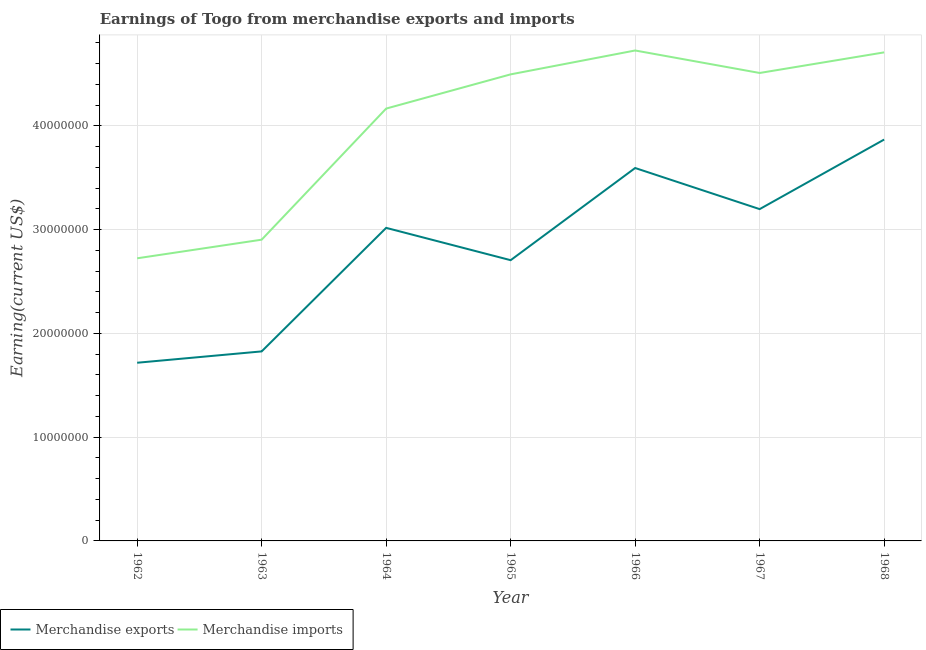Does the line corresponding to earnings from merchandise imports intersect with the line corresponding to earnings from merchandise exports?
Your answer should be very brief. No. Is the number of lines equal to the number of legend labels?
Offer a terse response. Yes. What is the earnings from merchandise imports in 1966?
Your response must be concise. 4.73e+07. Across all years, what is the maximum earnings from merchandise imports?
Keep it short and to the point. 4.73e+07. Across all years, what is the minimum earnings from merchandise imports?
Provide a succinct answer. 2.72e+07. In which year was the earnings from merchandise exports maximum?
Provide a short and direct response. 1968. In which year was the earnings from merchandise imports minimum?
Your answer should be compact. 1962. What is the total earnings from merchandise imports in the graph?
Offer a very short reply. 2.82e+08. What is the difference between the earnings from merchandise exports in 1962 and that in 1966?
Give a very brief answer. -1.88e+07. What is the difference between the earnings from merchandise imports in 1968 and the earnings from merchandise exports in 1963?
Your answer should be very brief. 2.88e+07. What is the average earnings from merchandise imports per year?
Keep it short and to the point. 4.03e+07. In the year 1964, what is the difference between the earnings from merchandise imports and earnings from merchandise exports?
Offer a terse response. 1.15e+07. In how many years, is the earnings from merchandise imports greater than 6000000 US$?
Make the answer very short. 7. What is the ratio of the earnings from merchandise exports in 1964 to that in 1967?
Offer a terse response. 0.94. Is the difference between the earnings from merchandise exports in 1967 and 1968 greater than the difference between the earnings from merchandise imports in 1967 and 1968?
Your answer should be compact. No. What is the difference between the highest and the second highest earnings from merchandise exports?
Offer a very short reply. 2.74e+06. What is the difference between the highest and the lowest earnings from merchandise exports?
Make the answer very short. 2.15e+07. Does the earnings from merchandise exports monotonically increase over the years?
Offer a very short reply. No. Is the earnings from merchandise exports strictly less than the earnings from merchandise imports over the years?
Offer a very short reply. Yes. How many lines are there?
Keep it short and to the point. 2. Does the graph contain any zero values?
Your answer should be compact. No. Does the graph contain grids?
Keep it short and to the point. Yes. Where does the legend appear in the graph?
Your answer should be very brief. Bottom left. How many legend labels are there?
Provide a short and direct response. 2. How are the legend labels stacked?
Provide a short and direct response. Horizontal. What is the title of the graph?
Provide a succinct answer. Earnings of Togo from merchandise exports and imports. What is the label or title of the X-axis?
Give a very brief answer. Year. What is the label or title of the Y-axis?
Your answer should be very brief. Earning(current US$). What is the Earning(current US$) of Merchandise exports in 1962?
Give a very brief answer. 1.72e+07. What is the Earning(current US$) of Merchandise imports in 1962?
Your answer should be compact. 2.72e+07. What is the Earning(current US$) of Merchandise exports in 1963?
Offer a very short reply. 1.83e+07. What is the Earning(current US$) in Merchandise imports in 1963?
Provide a short and direct response. 2.90e+07. What is the Earning(current US$) in Merchandise exports in 1964?
Give a very brief answer. 3.02e+07. What is the Earning(current US$) in Merchandise imports in 1964?
Offer a very short reply. 4.17e+07. What is the Earning(current US$) in Merchandise exports in 1965?
Provide a short and direct response. 2.71e+07. What is the Earning(current US$) of Merchandise imports in 1965?
Your response must be concise. 4.50e+07. What is the Earning(current US$) of Merchandise exports in 1966?
Provide a short and direct response. 3.59e+07. What is the Earning(current US$) of Merchandise imports in 1966?
Your response must be concise. 4.73e+07. What is the Earning(current US$) in Merchandise exports in 1967?
Give a very brief answer. 3.20e+07. What is the Earning(current US$) of Merchandise imports in 1967?
Provide a succinct answer. 4.51e+07. What is the Earning(current US$) of Merchandise exports in 1968?
Offer a very short reply. 3.87e+07. What is the Earning(current US$) of Merchandise imports in 1968?
Your answer should be compact. 4.71e+07. Across all years, what is the maximum Earning(current US$) in Merchandise exports?
Provide a short and direct response. 3.87e+07. Across all years, what is the maximum Earning(current US$) in Merchandise imports?
Give a very brief answer. 4.73e+07. Across all years, what is the minimum Earning(current US$) in Merchandise exports?
Offer a terse response. 1.72e+07. Across all years, what is the minimum Earning(current US$) of Merchandise imports?
Your response must be concise. 2.72e+07. What is the total Earning(current US$) of Merchandise exports in the graph?
Ensure brevity in your answer.  1.99e+08. What is the total Earning(current US$) in Merchandise imports in the graph?
Make the answer very short. 2.82e+08. What is the difference between the Earning(current US$) in Merchandise exports in 1962 and that in 1963?
Your answer should be compact. -1.09e+06. What is the difference between the Earning(current US$) in Merchandise imports in 1962 and that in 1963?
Make the answer very short. -1.79e+06. What is the difference between the Earning(current US$) of Merchandise exports in 1962 and that in 1964?
Ensure brevity in your answer.  -1.30e+07. What is the difference between the Earning(current US$) of Merchandise imports in 1962 and that in 1964?
Ensure brevity in your answer.  -1.44e+07. What is the difference between the Earning(current US$) in Merchandise exports in 1962 and that in 1965?
Your answer should be compact. -9.88e+06. What is the difference between the Earning(current US$) of Merchandise imports in 1962 and that in 1965?
Your response must be concise. -1.77e+07. What is the difference between the Earning(current US$) in Merchandise exports in 1962 and that in 1966?
Your answer should be compact. -1.88e+07. What is the difference between the Earning(current US$) in Merchandise imports in 1962 and that in 1966?
Make the answer very short. -2.00e+07. What is the difference between the Earning(current US$) in Merchandise exports in 1962 and that in 1967?
Provide a short and direct response. -1.48e+07. What is the difference between the Earning(current US$) in Merchandise imports in 1962 and that in 1967?
Your answer should be very brief. -1.79e+07. What is the difference between the Earning(current US$) in Merchandise exports in 1962 and that in 1968?
Offer a very short reply. -2.15e+07. What is the difference between the Earning(current US$) of Merchandise imports in 1962 and that in 1968?
Your answer should be very brief. -1.98e+07. What is the difference between the Earning(current US$) in Merchandise exports in 1963 and that in 1964?
Your answer should be very brief. -1.19e+07. What is the difference between the Earning(current US$) of Merchandise imports in 1963 and that in 1964?
Keep it short and to the point. -1.26e+07. What is the difference between the Earning(current US$) of Merchandise exports in 1963 and that in 1965?
Your response must be concise. -8.79e+06. What is the difference between the Earning(current US$) of Merchandise imports in 1963 and that in 1965?
Your response must be concise. -1.59e+07. What is the difference between the Earning(current US$) in Merchandise exports in 1963 and that in 1966?
Offer a terse response. -1.77e+07. What is the difference between the Earning(current US$) in Merchandise imports in 1963 and that in 1966?
Make the answer very short. -1.82e+07. What is the difference between the Earning(current US$) of Merchandise exports in 1963 and that in 1967?
Your answer should be compact. -1.37e+07. What is the difference between the Earning(current US$) in Merchandise imports in 1963 and that in 1967?
Ensure brevity in your answer.  -1.61e+07. What is the difference between the Earning(current US$) of Merchandise exports in 1963 and that in 1968?
Your answer should be compact. -2.04e+07. What is the difference between the Earning(current US$) in Merchandise imports in 1963 and that in 1968?
Ensure brevity in your answer.  -1.81e+07. What is the difference between the Earning(current US$) in Merchandise exports in 1964 and that in 1965?
Make the answer very short. 3.12e+06. What is the difference between the Earning(current US$) in Merchandise imports in 1964 and that in 1965?
Keep it short and to the point. -3.30e+06. What is the difference between the Earning(current US$) of Merchandise exports in 1964 and that in 1966?
Offer a very short reply. -5.77e+06. What is the difference between the Earning(current US$) of Merchandise imports in 1964 and that in 1966?
Your answer should be compact. -5.60e+06. What is the difference between the Earning(current US$) of Merchandise exports in 1964 and that in 1967?
Your answer should be very brief. -1.81e+06. What is the difference between the Earning(current US$) in Merchandise imports in 1964 and that in 1967?
Your response must be concise. -3.43e+06. What is the difference between the Earning(current US$) of Merchandise exports in 1964 and that in 1968?
Make the answer very short. -8.51e+06. What is the difference between the Earning(current US$) of Merchandise imports in 1964 and that in 1968?
Your answer should be compact. -5.42e+06. What is the difference between the Earning(current US$) of Merchandise exports in 1965 and that in 1966?
Your answer should be compact. -8.88e+06. What is the difference between the Earning(current US$) of Merchandise imports in 1965 and that in 1966?
Offer a very short reply. -2.30e+06. What is the difference between the Earning(current US$) of Merchandise exports in 1965 and that in 1967?
Keep it short and to the point. -4.92e+06. What is the difference between the Earning(current US$) in Merchandise imports in 1965 and that in 1967?
Provide a short and direct response. -1.34e+05. What is the difference between the Earning(current US$) of Merchandise exports in 1965 and that in 1968?
Provide a short and direct response. -1.16e+07. What is the difference between the Earning(current US$) of Merchandise imports in 1965 and that in 1968?
Keep it short and to the point. -2.12e+06. What is the difference between the Earning(current US$) of Merchandise exports in 1966 and that in 1967?
Your answer should be compact. 3.96e+06. What is the difference between the Earning(current US$) of Merchandise imports in 1966 and that in 1967?
Provide a succinct answer. 2.17e+06. What is the difference between the Earning(current US$) in Merchandise exports in 1966 and that in 1968?
Make the answer very short. -2.74e+06. What is the difference between the Earning(current US$) of Merchandise imports in 1966 and that in 1968?
Offer a very short reply. 1.82e+05. What is the difference between the Earning(current US$) of Merchandise exports in 1967 and that in 1968?
Your answer should be very brief. -6.70e+06. What is the difference between the Earning(current US$) in Merchandise imports in 1967 and that in 1968?
Offer a terse response. -1.98e+06. What is the difference between the Earning(current US$) of Merchandise exports in 1962 and the Earning(current US$) of Merchandise imports in 1963?
Give a very brief answer. -1.19e+07. What is the difference between the Earning(current US$) in Merchandise exports in 1962 and the Earning(current US$) in Merchandise imports in 1964?
Offer a terse response. -2.45e+07. What is the difference between the Earning(current US$) in Merchandise exports in 1962 and the Earning(current US$) in Merchandise imports in 1965?
Keep it short and to the point. -2.78e+07. What is the difference between the Earning(current US$) of Merchandise exports in 1962 and the Earning(current US$) of Merchandise imports in 1966?
Your answer should be compact. -3.01e+07. What is the difference between the Earning(current US$) in Merchandise exports in 1962 and the Earning(current US$) in Merchandise imports in 1967?
Your response must be concise. -2.79e+07. What is the difference between the Earning(current US$) of Merchandise exports in 1962 and the Earning(current US$) of Merchandise imports in 1968?
Offer a very short reply. -2.99e+07. What is the difference between the Earning(current US$) of Merchandise exports in 1963 and the Earning(current US$) of Merchandise imports in 1964?
Ensure brevity in your answer.  -2.34e+07. What is the difference between the Earning(current US$) in Merchandise exports in 1963 and the Earning(current US$) in Merchandise imports in 1965?
Keep it short and to the point. -2.67e+07. What is the difference between the Earning(current US$) of Merchandise exports in 1963 and the Earning(current US$) of Merchandise imports in 1966?
Ensure brevity in your answer.  -2.90e+07. What is the difference between the Earning(current US$) in Merchandise exports in 1963 and the Earning(current US$) in Merchandise imports in 1967?
Keep it short and to the point. -2.68e+07. What is the difference between the Earning(current US$) in Merchandise exports in 1963 and the Earning(current US$) in Merchandise imports in 1968?
Your answer should be very brief. -2.88e+07. What is the difference between the Earning(current US$) of Merchandise exports in 1964 and the Earning(current US$) of Merchandise imports in 1965?
Provide a succinct answer. -1.48e+07. What is the difference between the Earning(current US$) in Merchandise exports in 1964 and the Earning(current US$) in Merchandise imports in 1966?
Offer a terse response. -1.71e+07. What is the difference between the Earning(current US$) in Merchandise exports in 1964 and the Earning(current US$) in Merchandise imports in 1967?
Provide a short and direct response. -1.49e+07. What is the difference between the Earning(current US$) in Merchandise exports in 1964 and the Earning(current US$) in Merchandise imports in 1968?
Offer a very short reply. -1.69e+07. What is the difference between the Earning(current US$) of Merchandise exports in 1965 and the Earning(current US$) of Merchandise imports in 1966?
Your answer should be very brief. -2.02e+07. What is the difference between the Earning(current US$) of Merchandise exports in 1965 and the Earning(current US$) of Merchandise imports in 1967?
Your response must be concise. -1.80e+07. What is the difference between the Earning(current US$) in Merchandise exports in 1965 and the Earning(current US$) in Merchandise imports in 1968?
Make the answer very short. -2.00e+07. What is the difference between the Earning(current US$) in Merchandise exports in 1966 and the Earning(current US$) in Merchandise imports in 1967?
Give a very brief answer. -9.16e+06. What is the difference between the Earning(current US$) of Merchandise exports in 1966 and the Earning(current US$) of Merchandise imports in 1968?
Provide a short and direct response. -1.11e+07. What is the difference between the Earning(current US$) in Merchandise exports in 1967 and the Earning(current US$) in Merchandise imports in 1968?
Provide a short and direct response. -1.51e+07. What is the average Earning(current US$) in Merchandise exports per year?
Your answer should be very brief. 2.85e+07. What is the average Earning(current US$) of Merchandise imports per year?
Your answer should be very brief. 4.03e+07. In the year 1962, what is the difference between the Earning(current US$) of Merchandise exports and Earning(current US$) of Merchandise imports?
Your answer should be compact. -1.01e+07. In the year 1963, what is the difference between the Earning(current US$) of Merchandise exports and Earning(current US$) of Merchandise imports?
Your answer should be very brief. -1.08e+07. In the year 1964, what is the difference between the Earning(current US$) of Merchandise exports and Earning(current US$) of Merchandise imports?
Offer a terse response. -1.15e+07. In the year 1965, what is the difference between the Earning(current US$) in Merchandise exports and Earning(current US$) in Merchandise imports?
Give a very brief answer. -1.79e+07. In the year 1966, what is the difference between the Earning(current US$) of Merchandise exports and Earning(current US$) of Merchandise imports?
Your response must be concise. -1.13e+07. In the year 1967, what is the difference between the Earning(current US$) of Merchandise exports and Earning(current US$) of Merchandise imports?
Your response must be concise. -1.31e+07. In the year 1968, what is the difference between the Earning(current US$) in Merchandise exports and Earning(current US$) in Merchandise imports?
Your response must be concise. -8.40e+06. What is the ratio of the Earning(current US$) of Merchandise exports in 1962 to that in 1963?
Offer a very short reply. 0.94. What is the ratio of the Earning(current US$) of Merchandise imports in 1962 to that in 1963?
Make the answer very short. 0.94. What is the ratio of the Earning(current US$) of Merchandise exports in 1962 to that in 1964?
Your response must be concise. 0.57. What is the ratio of the Earning(current US$) in Merchandise imports in 1962 to that in 1964?
Offer a terse response. 0.65. What is the ratio of the Earning(current US$) of Merchandise exports in 1962 to that in 1965?
Keep it short and to the point. 0.63. What is the ratio of the Earning(current US$) of Merchandise imports in 1962 to that in 1965?
Your response must be concise. 0.61. What is the ratio of the Earning(current US$) in Merchandise exports in 1962 to that in 1966?
Provide a short and direct response. 0.48. What is the ratio of the Earning(current US$) of Merchandise imports in 1962 to that in 1966?
Offer a terse response. 0.58. What is the ratio of the Earning(current US$) of Merchandise exports in 1962 to that in 1967?
Your response must be concise. 0.54. What is the ratio of the Earning(current US$) in Merchandise imports in 1962 to that in 1967?
Provide a succinct answer. 0.6. What is the ratio of the Earning(current US$) of Merchandise exports in 1962 to that in 1968?
Ensure brevity in your answer.  0.44. What is the ratio of the Earning(current US$) of Merchandise imports in 1962 to that in 1968?
Ensure brevity in your answer.  0.58. What is the ratio of the Earning(current US$) of Merchandise exports in 1963 to that in 1964?
Your answer should be very brief. 0.61. What is the ratio of the Earning(current US$) in Merchandise imports in 1963 to that in 1964?
Offer a very short reply. 0.7. What is the ratio of the Earning(current US$) in Merchandise exports in 1963 to that in 1965?
Ensure brevity in your answer.  0.68. What is the ratio of the Earning(current US$) in Merchandise imports in 1963 to that in 1965?
Your answer should be very brief. 0.65. What is the ratio of the Earning(current US$) in Merchandise exports in 1963 to that in 1966?
Ensure brevity in your answer.  0.51. What is the ratio of the Earning(current US$) in Merchandise imports in 1963 to that in 1966?
Give a very brief answer. 0.61. What is the ratio of the Earning(current US$) of Merchandise exports in 1963 to that in 1967?
Keep it short and to the point. 0.57. What is the ratio of the Earning(current US$) of Merchandise imports in 1963 to that in 1967?
Your answer should be very brief. 0.64. What is the ratio of the Earning(current US$) of Merchandise exports in 1963 to that in 1968?
Your answer should be compact. 0.47. What is the ratio of the Earning(current US$) in Merchandise imports in 1963 to that in 1968?
Ensure brevity in your answer.  0.62. What is the ratio of the Earning(current US$) in Merchandise exports in 1964 to that in 1965?
Provide a short and direct response. 1.12. What is the ratio of the Earning(current US$) in Merchandise imports in 1964 to that in 1965?
Ensure brevity in your answer.  0.93. What is the ratio of the Earning(current US$) in Merchandise exports in 1964 to that in 1966?
Ensure brevity in your answer.  0.84. What is the ratio of the Earning(current US$) in Merchandise imports in 1964 to that in 1966?
Your response must be concise. 0.88. What is the ratio of the Earning(current US$) of Merchandise exports in 1964 to that in 1967?
Make the answer very short. 0.94. What is the ratio of the Earning(current US$) in Merchandise imports in 1964 to that in 1967?
Offer a very short reply. 0.92. What is the ratio of the Earning(current US$) in Merchandise exports in 1964 to that in 1968?
Give a very brief answer. 0.78. What is the ratio of the Earning(current US$) in Merchandise imports in 1964 to that in 1968?
Offer a terse response. 0.89. What is the ratio of the Earning(current US$) in Merchandise exports in 1965 to that in 1966?
Provide a short and direct response. 0.75. What is the ratio of the Earning(current US$) of Merchandise imports in 1965 to that in 1966?
Keep it short and to the point. 0.95. What is the ratio of the Earning(current US$) in Merchandise exports in 1965 to that in 1967?
Ensure brevity in your answer.  0.85. What is the ratio of the Earning(current US$) of Merchandise exports in 1965 to that in 1968?
Provide a succinct answer. 0.7. What is the ratio of the Earning(current US$) in Merchandise imports in 1965 to that in 1968?
Offer a terse response. 0.95. What is the ratio of the Earning(current US$) of Merchandise exports in 1966 to that in 1967?
Provide a succinct answer. 1.12. What is the ratio of the Earning(current US$) in Merchandise imports in 1966 to that in 1967?
Make the answer very short. 1.05. What is the ratio of the Earning(current US$) in Merchandise exports in 1966 to that in 1968?
Your response must be concise. 0.93. What is the ratio of the Earning(current US$) of Merchandise exports in 1967 to that in 1968?
Make the answer very short. 0.83. What is the ratio of the Earning(current US$) of Merchandise imports in 1967 to that in 1968?
Ensure brevity in your answer.  0.96. What is the difference between the highest and the second highest Earning(current US$) of Merchandise exports?
Provide a short and direct response. 2.74e+06. What is the difference between the highest and the second highest Earning(current US$) in Merchandise imports?
Offer a very short reply. 1.82e+05. What is the difference between the highest and the lowest Earning(current US$) of Merchandise exports?
Provide a short and direct response. 2.15e+07. What is the difference between the highest and the lowest Earning(current US$) of Merchandise imports?
Offer a very short reply. 2.00e+07. 